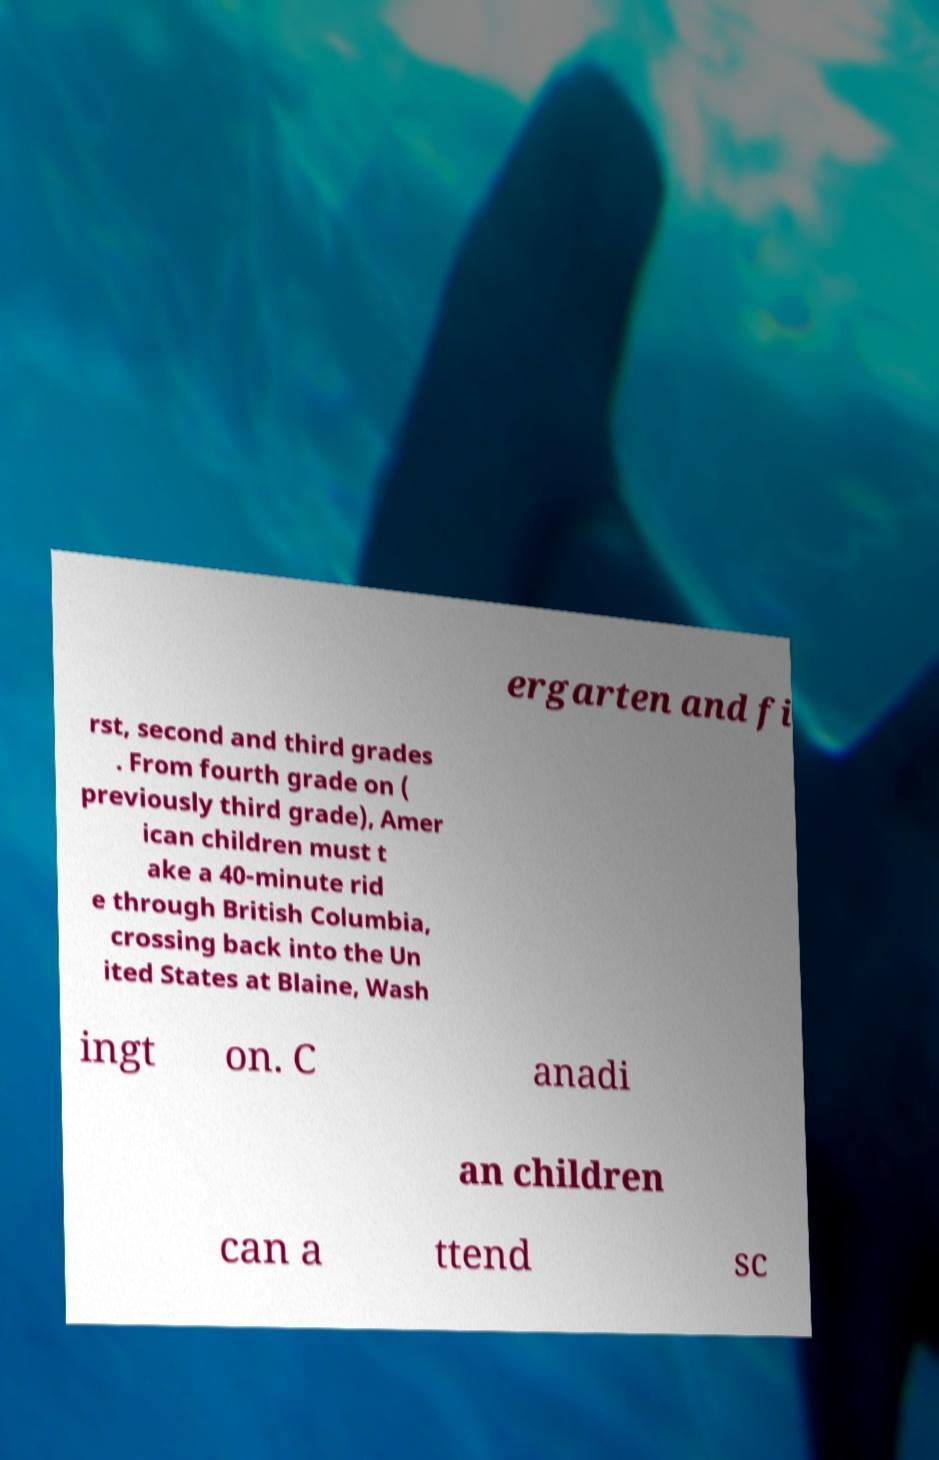For documentation purposes, I need the text within this image transcribed. Could you provide that? ergarten and fi rst, second and third grades . From fourth grade on ( previously third grade), Amer ican children must t ake a 40-minute rid e through British Columbia, crossing back into the Un ited States at Blaine, Wash ingt on. C anadi an children can a ttend sc 